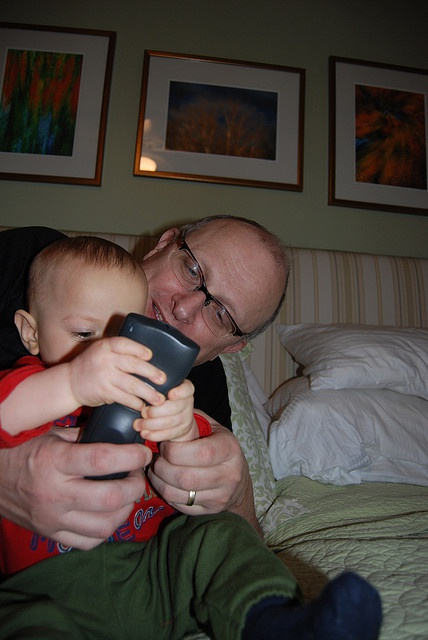Describe the objects in this image and their specific colors. I can see couch in black and gray tones, bed in black and gray tones, people in black, gray, brown, and darkgray tones, people in black, darkgray, and gray tones, and remote in black, darkblue, and gray tones in this image. 